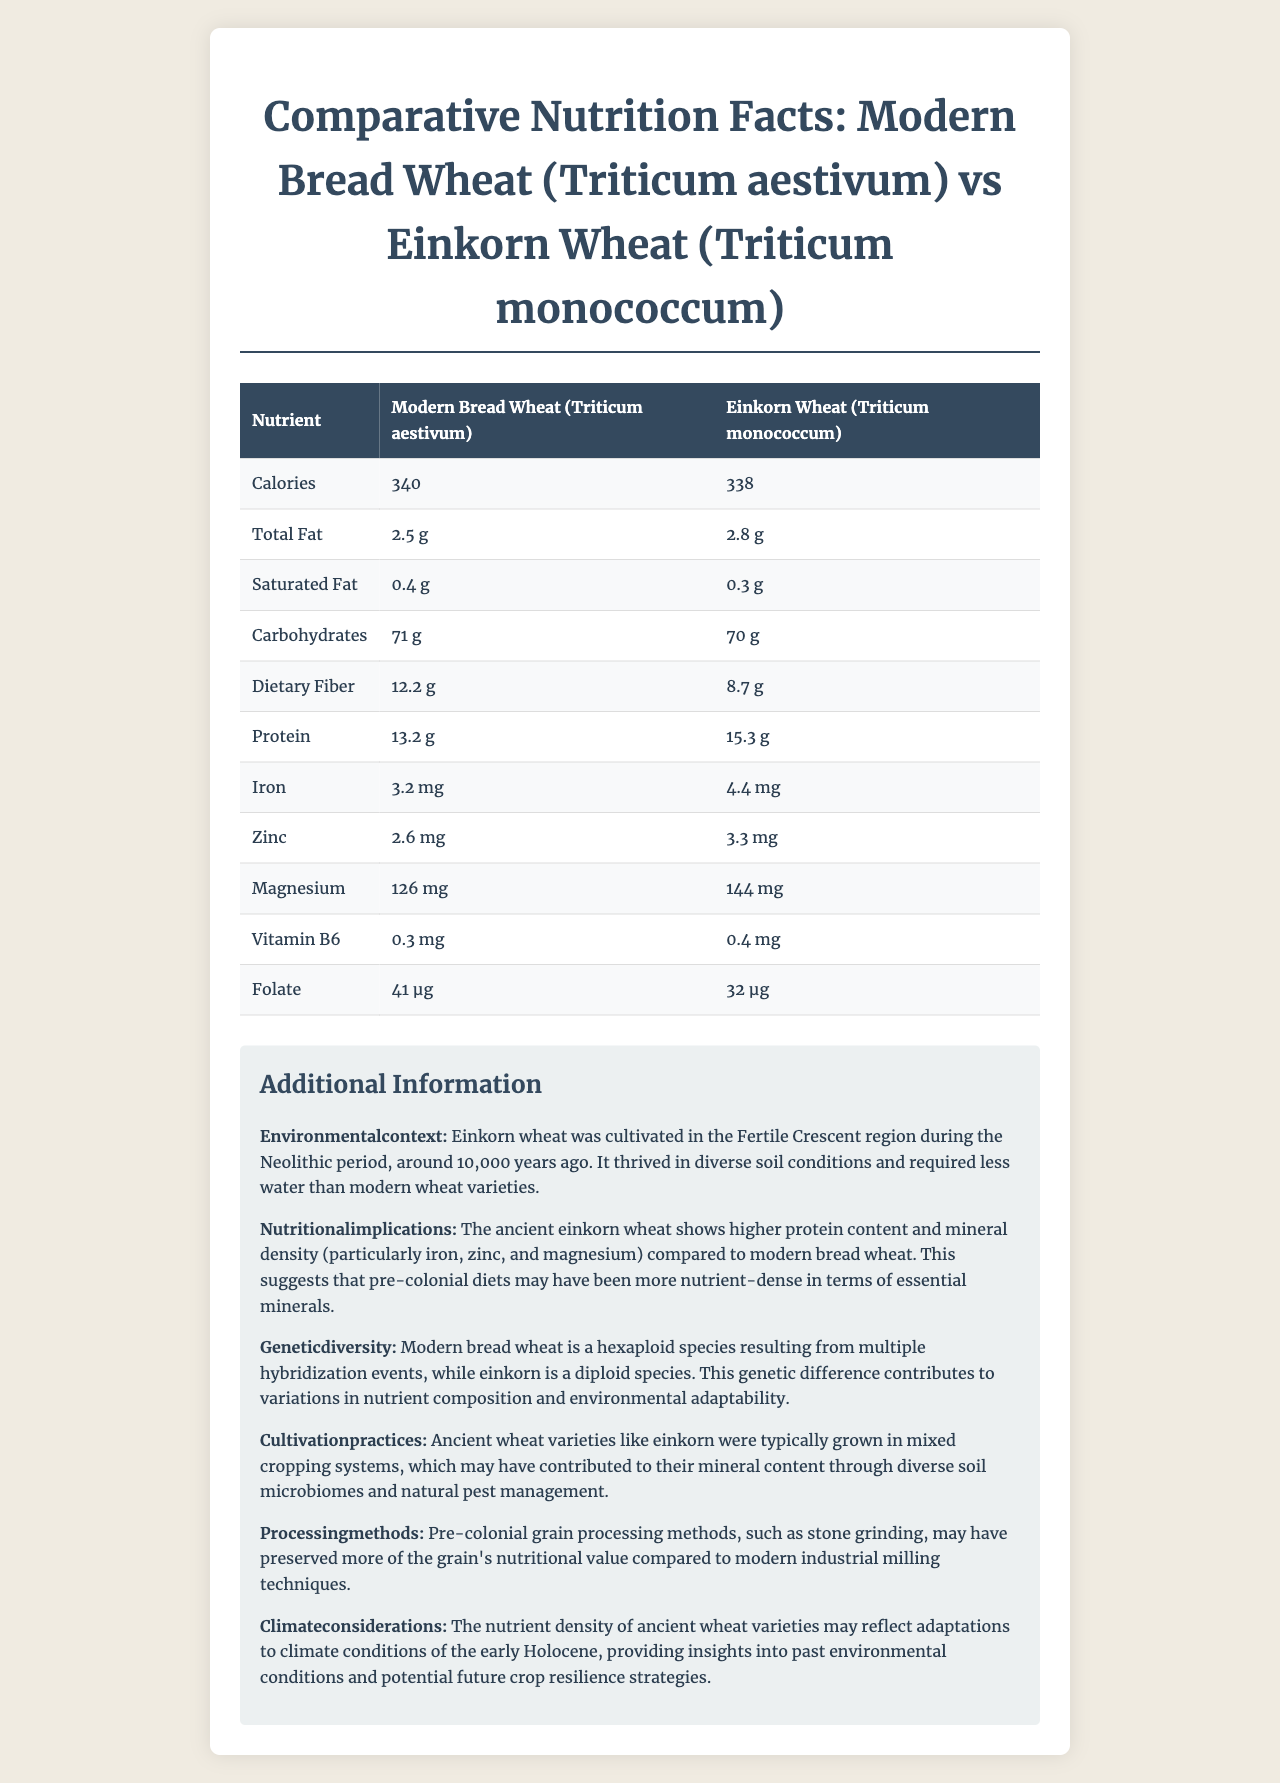what is the current calorie content of 100g of Modern Bread Wheat? The document states that Modern Bread Wheat has 340 calories per 100g serving.
Answer: 340 calories how much protein does Einkorn Wheat contain per 100g serving? The document indicates that Einkorn Wheat contains 15.3g of protein per 100g serving.
Answer: 15.3g is the dietary fiber higher in Modern Bread Wheat or Einkorn Wheat? The document shows that Modern Bread Wheat has 12.2g of dietary fiber, whereas Einkorn Wheat has 8.7g.
Answer: Modern Bread Wheat what is the serving size mentioned in the document? The serving size stated at the beginning of the document is 100g.
Answer: 100g what is the iron content in Einkorn Wheat? According to the document, Einkorn Wheat contains 4.4 mg of iron.
Answer: 4.4 mg which wheat variant has higher magnesium content? A. Modern Bread Wheat B. Einkorn Wheat C. Both have the same content The document states that Einkorn Wheat has 144 mg of magnesium compared to Modern Bread Wheat's 126 mg.
Answer: B. Einkorn Wheat which nutrient is lower in Einkorn Wheat compared to Modern Bread Wheat in terms of total fat? A. Total Fat B. Saturated Fat C. Carbohydrates D. Dietary Fiber Einkorn Wheat has 0.3g of Saturated Fat, which is lower than the 0.4g found in Modern Bread Wheat.
Answer: B. Saturated Fat does the document mention the cultivation practices for ancient wheat varieties like Einkorn Wheat? The document explains that ancient wheat varieties like Einkorn Wheat were typically grown in mixed cropping systems, which may have contributed to their mineral content.
Answer: Yes does modern bread wheat have higher folate content than einkorn wheat? The document shows that Modern Bread Wheat has 41 µg of folate, whereas Einkorn Wheat has 32 µg.
Answer: Yes summarize the main differences in nutrient density between Modern Bread Wheat and Einkorn Wheat. Modern Bread Wheat has higher dietary fiber and folate compared to Einkorn Wheat. However, Einkorn Wheat is richer in essential nutrients such as protein, iron, zinc, and magnesium. The document provides additional context, explaining the ancient cultivation practices, genetic differences, and environmental adaptations that have contributed to these nutritional disparities.
Answer: Modern Bread Wheat contains more dietary fiber and folate, but Einkorn Wheat has higher protein, mineral content (iron, zinc, magnesium), and slight differences in other nutrients like total fat and saturated fat. The document also discusses historical and environmental contexts affecting these differences. what are the environmental conditions mentioned in the document for the cultivation of Einkorn Wheat? The document mentions that Einkorn Wheat was cultivated in the Fertile Crescent region during the Neolithic period. It thrived in diverse soil conditions and required less water than modern wheat varieties.
Answer: Fertile Crescent region during the Neolithic period, thriving in diverse soil conditions and requiring less water. how does einkorn wheat's mineral content compare to that of modern bread wheat, according to the document? The document indicates that Einkorn Wheat shows higher mineral content, particularly in iron (4.4 mg vs. 3.2 mg), zinc (3.3 mg vs. 2.6 mg), and magnesium (144 mg vs. 126 mg).
Answer: Higher in Einkorn Wheat which wheat variant has more zinc content? The document states that Einkorn Wheat has 3.3 mg of zinc, whereas Modern Bread Wheat has 2.6 mg.
Answer: Einkorn Wheat what are the implications of the genetic diversity mentioned in the document? The document states that the genetic differences between the hexaploid Modern Bread Wheat and diploid Einkorn Wheat contribute to variations in nutrient composition and environmental adaptability.
Answer: Variations in nutrient composition and environmental adaptability. what are the historical processing methods for ancient grains mentioned in the document? The document states that pre-colonial grain processing methods such as stone grinding may have preserved more of the grain's nutritional value compared to modern industrial milling techniques.
Answer: Stone grinding. what was the climate adaptation of ancient wheat varieties like Einkorn Wheat? The document mentions that the nutrient density of ancient wheat varieties may reflect adaptations to climate conditions of the early Holocene.
Answer: Adaptations to the climate conditions of the early Holocene. why does modern bread wheat have higher folate content than Einkorn Wheat? The document provides nutritional information but does not explain why Modern Bread Wheat has a higher folate content than Einkorn Wheat.
Answer: Not enough information 